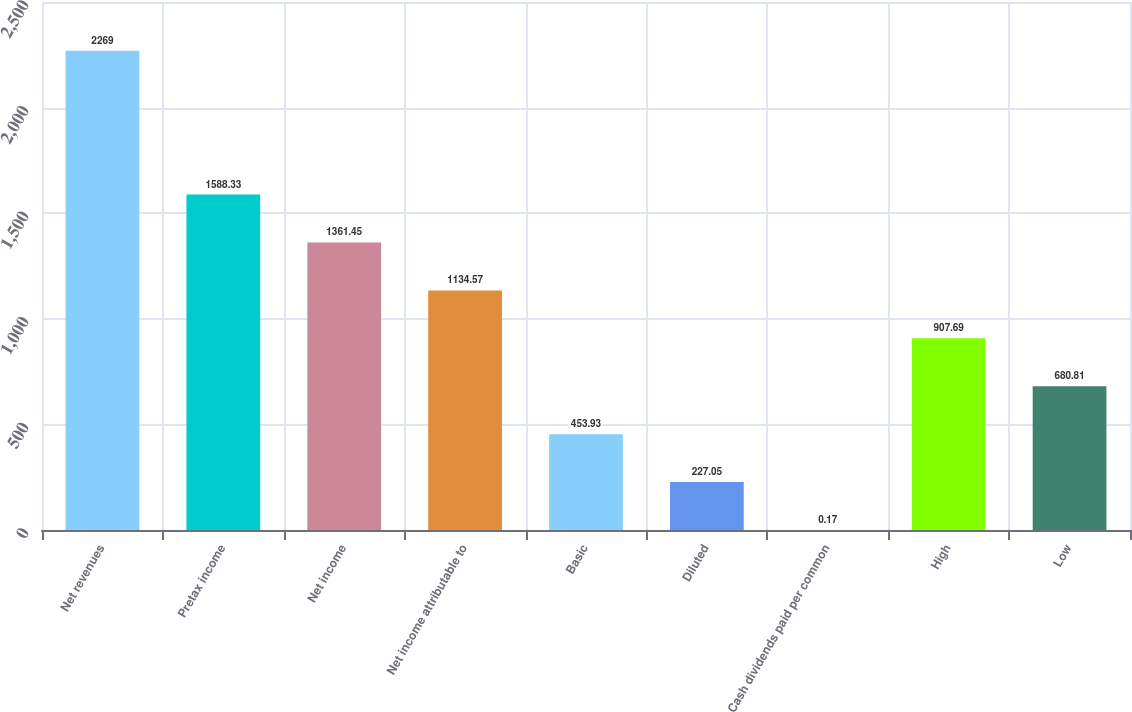Convert chart. <chart><loc_0><loc_0><loc_500><loc_500><bar_chart><fcel>Net revenues<fcel>Pretax income<fcel>Net income<fcel>Net income attributable to<fcel>Basic<fcel>Diluted<fcel>Cash dividends paid per common<fcel>High<fcel>Low<nl><fcel>2269<fcel>1588.33<fcel>1361.45<fcel>1134.57<fcel>453.93<fcel>227.05<fcel>0.17<fcel>907.69<fcel>680.81<nl></chart> 